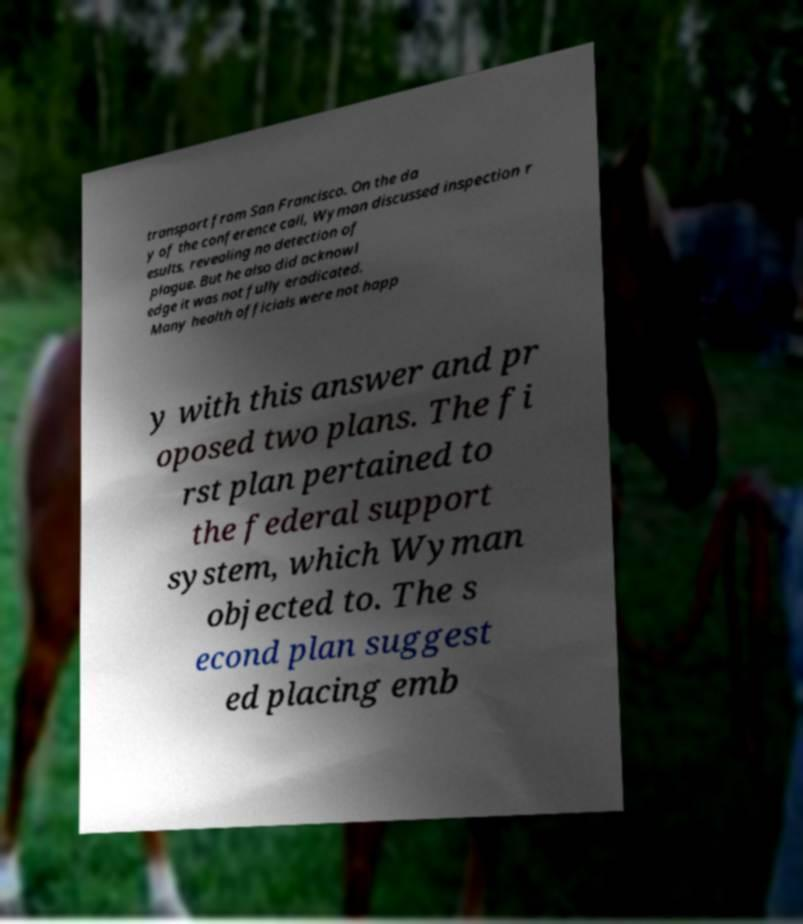I need the written content from this picture converted into text. Can you do that? transport from San Francisco. On the da y of the conference call, Wyman discussed inspection r esults, revealing no detection of plague. But he also did acknowl edge it was not fully eradicated. Many health officials were not happ y with this answer and pr oposed two plans. The fi rst plan pertained to the federal support system, which Wyman objected to. The s econd plan suggest ed placing emb 